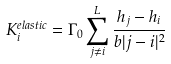Convert formula to latex. <formula><loc_0><loc_0><loc_500><loc_500>K _ { i } ^ { e l a s t i c } = \Gamma _ { 0 } \sum _ { j \neq i } ^ { L } \frac { h _ { j } - h _ { i } } { b | j - i | ^ { 2 } }</formula> 